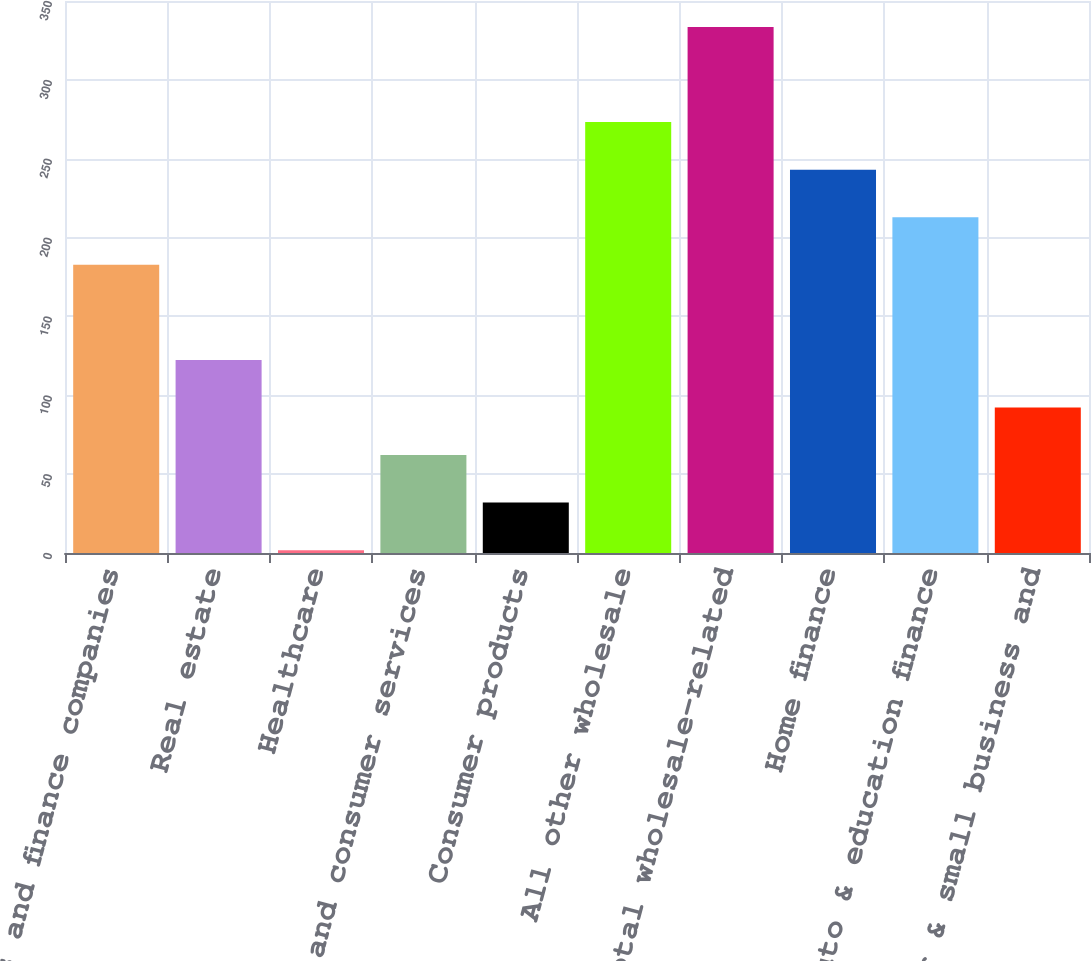Convert chart. <chart><loc_0><loc_0><loc_500><loc_500><bar_chart><fcel>Banks and finance companies<fcel>Real estate<fcel>Healthcare<fcel>Retail and consumer services<fcel>Consumer products<fcel>All other wholesale<fcel>Total wholesale-related<fcel>Home finance<fcel>Auto & education finance<fcel>Consumer & small business and<nl><fcel>182.76<fcel>122.44<fcel>1.8<fcel>62.12<fcel>31.96<fcel>273.24<fcel>333.56<fcel>243.08<fcel>212.92<fcel>92.28<nl></chart> 